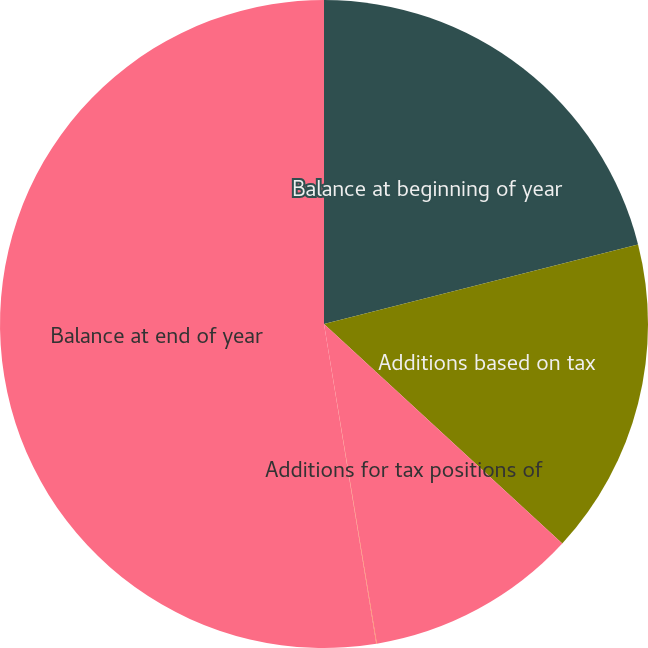Convert chart. <chart><loc_0><loc_0><loc_500><loc_500><pie_chart><fcel>Balance at beginning of year<fcel>Additions based on tax<fcel>Additions for tax positions of<fcel>Reductions for tax positions<fcel>Balance at end of year<nl><fcel>21.05%<fcel>15.8%<fcel>10.54%<fcel>0.03%<fcel>52.58%<nl></chart> 